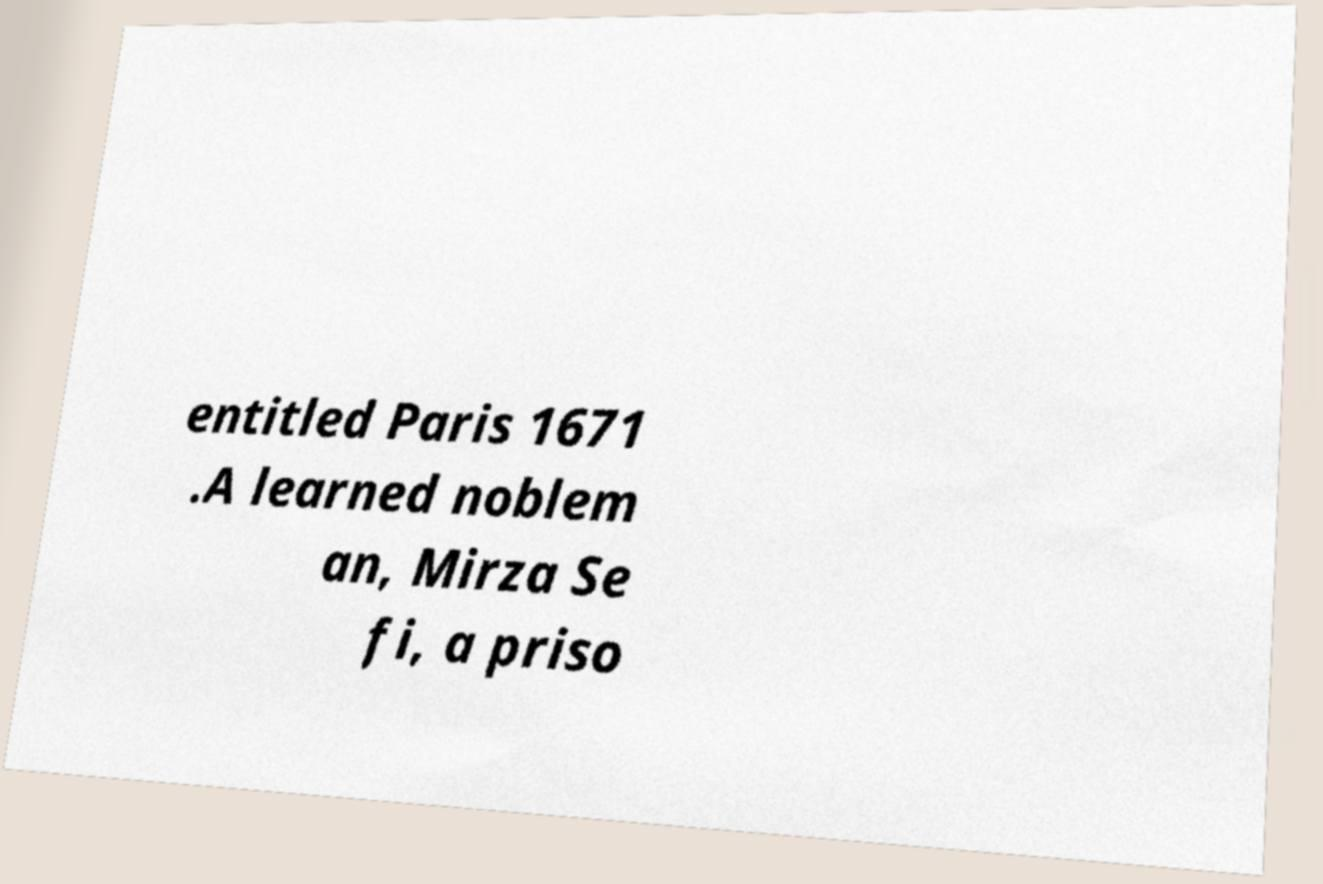Could you assist in decoding the text presented in this image and type it out clearly? entitled Paris 1671 .A learned noblem an, Mirza Se fi, a priso 